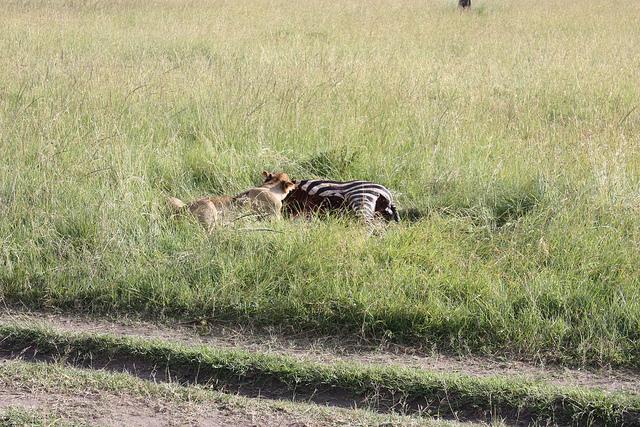Is there a lion in the photo?
Give a very brief answer. Yes. What is this zebra doing?
Answer briefly. Dying. What happened to the zebra?
Short answer required. Killed by lion. 